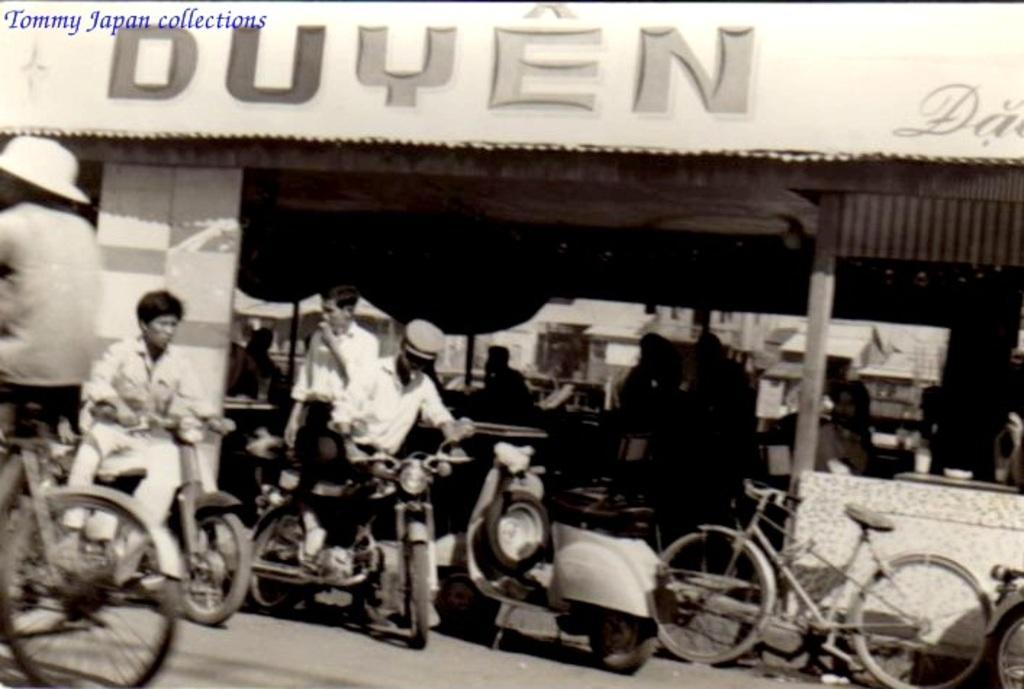How would you summarize this image in a sentence or two? In this picture I can see the vehicles on the road. I can see people sitting on the chair. I can see the hoarding. 